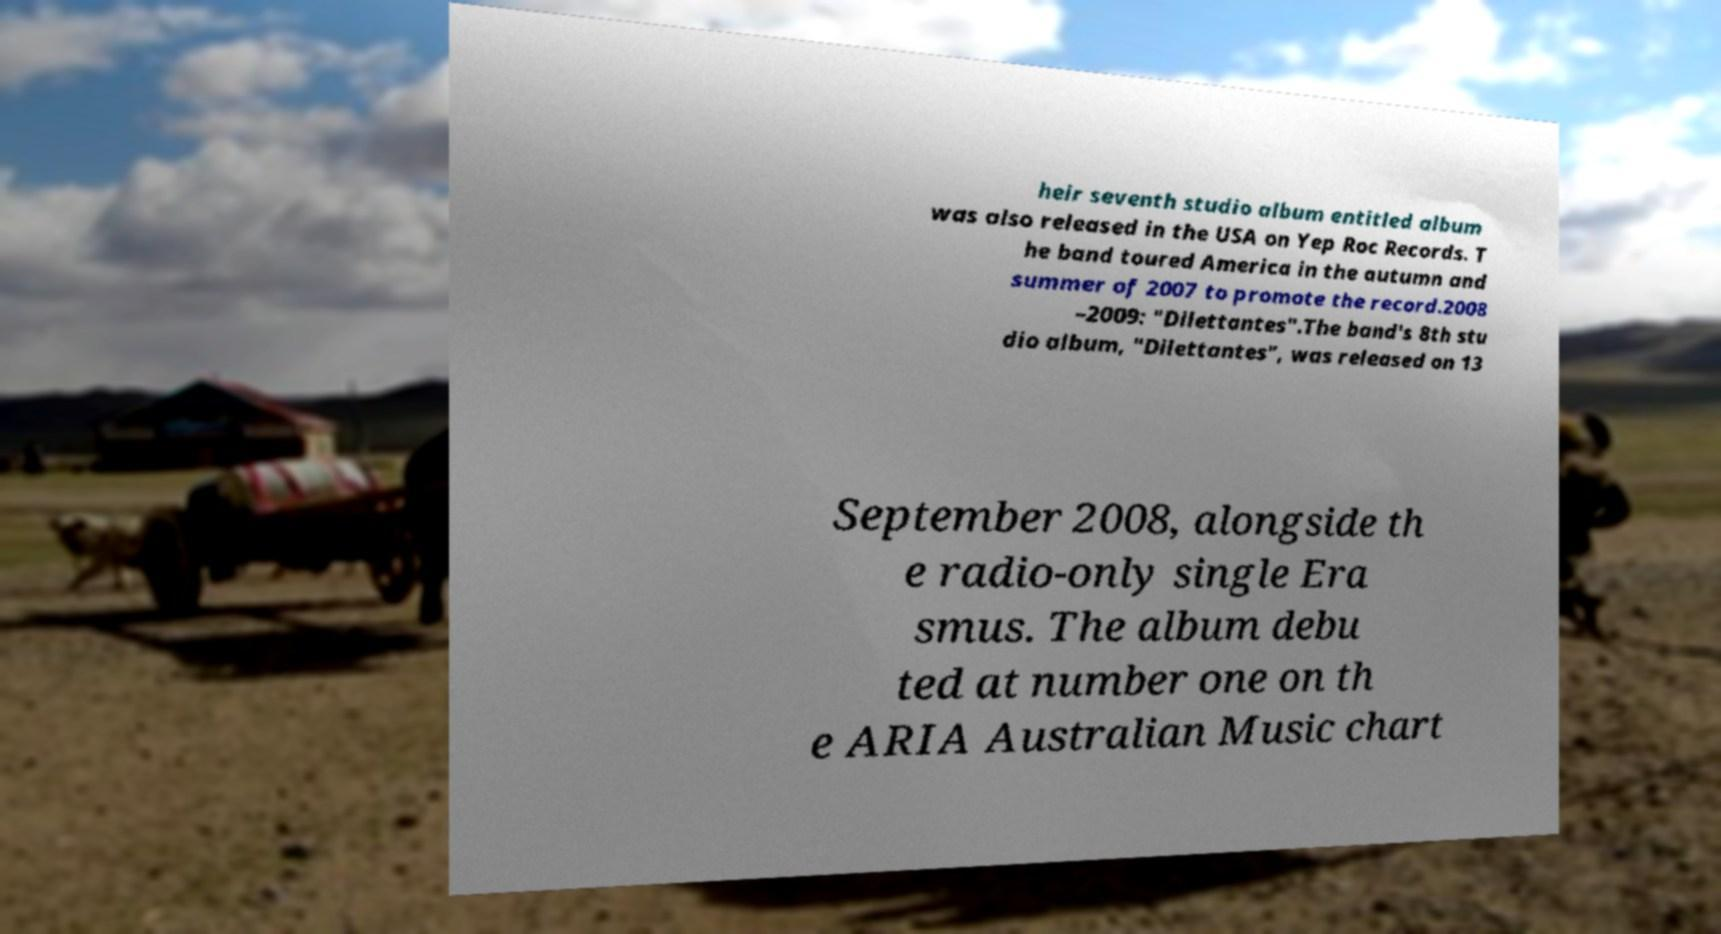For documentation purposes, I need the text within this image transcribed. Could you provide that? heir seventh studio album entitled album was also released in the USA on Yep Roc Records. T he band toured America in the autumn and summer of 2007 to promote the record.2008 –2009: "Dilettantes".The band's 8th stu dio album, "Dilettantes", was released on 13 September 2008, alongside th e radio-only single Era smus. The album debu ted at number one on th e ARIA Australian Music chart 